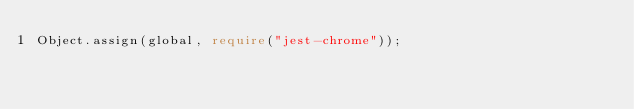Convert code to text. <code><loc_0><loc_0><loc_500><loc_500><_TypeScript_>Object.assign(global, require("jest-chrome"));
</code> 